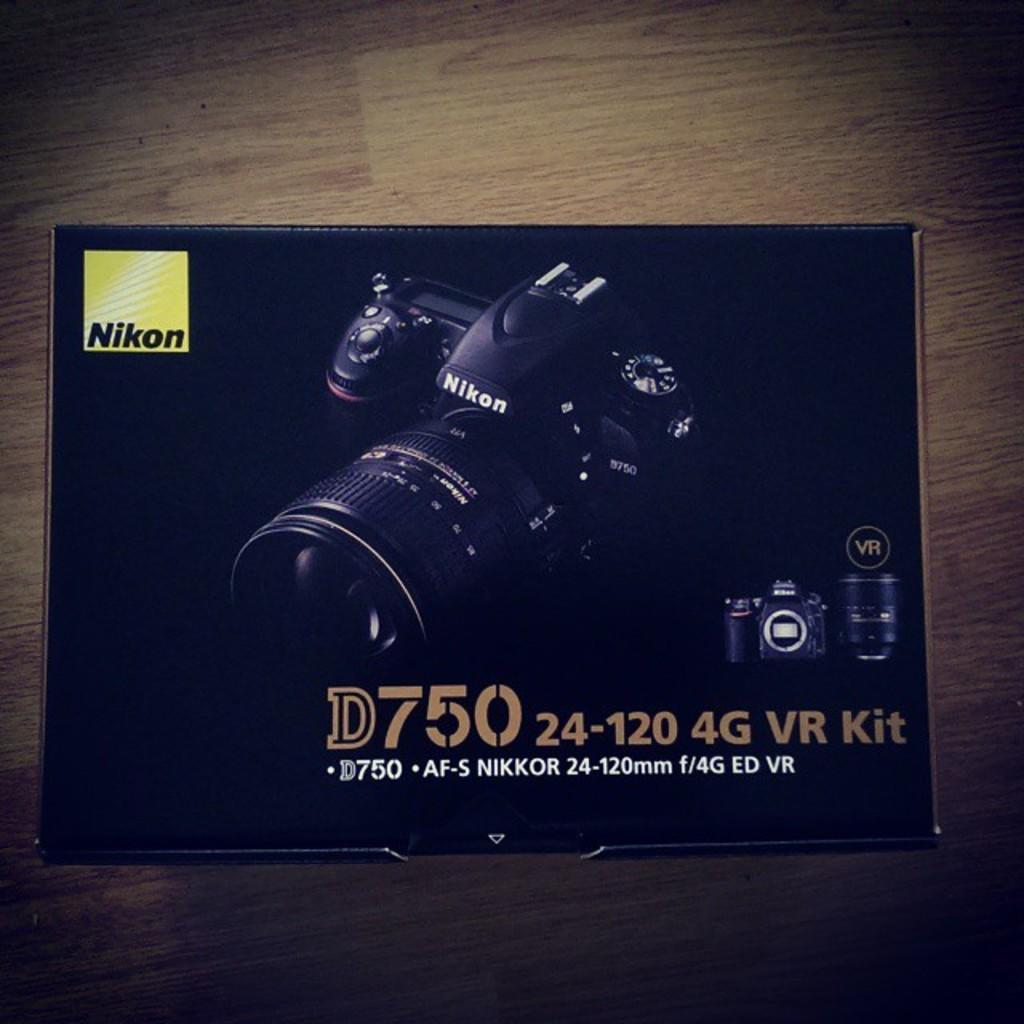What is the main subject in the center of the image? There is a paper in the center of the image. What can be found on the paper? The paper contains text and numbers, as well as pictures of a camera. What type of object can be seen in the background of the image? There is a wooden object in the background of the image. Where is the nerve located in the image? There is no nerve present in the image. What type of farming equipment can be seen in the image? There is no farming equipment, such as a plough, present in the image. 